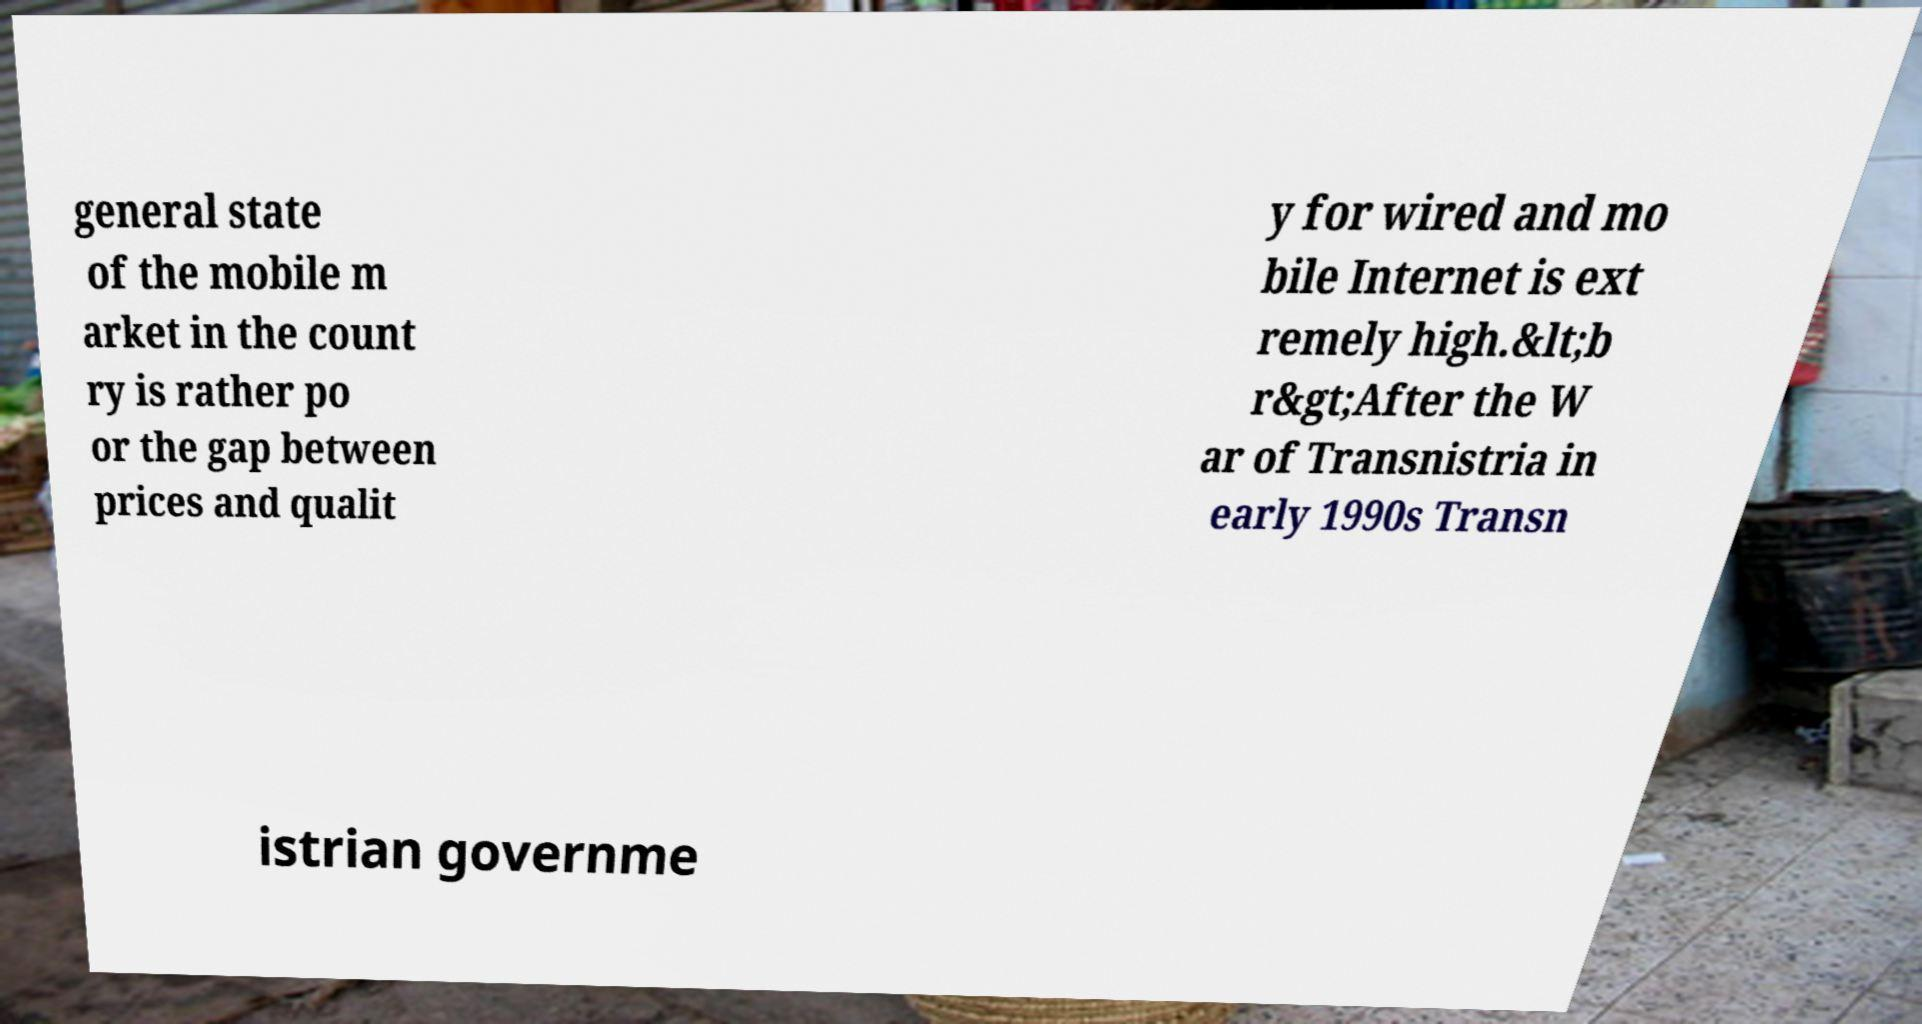Can you accurately transcribe the text from the provided image for me? general state of the mobile m arket in the count ry is rather po or the gap between prices and qualit y for wired and mo bile Internet is ext remely high.&lt;b r&gt;After the W ar of Transnistria in early 1990s Transn istrian governme 